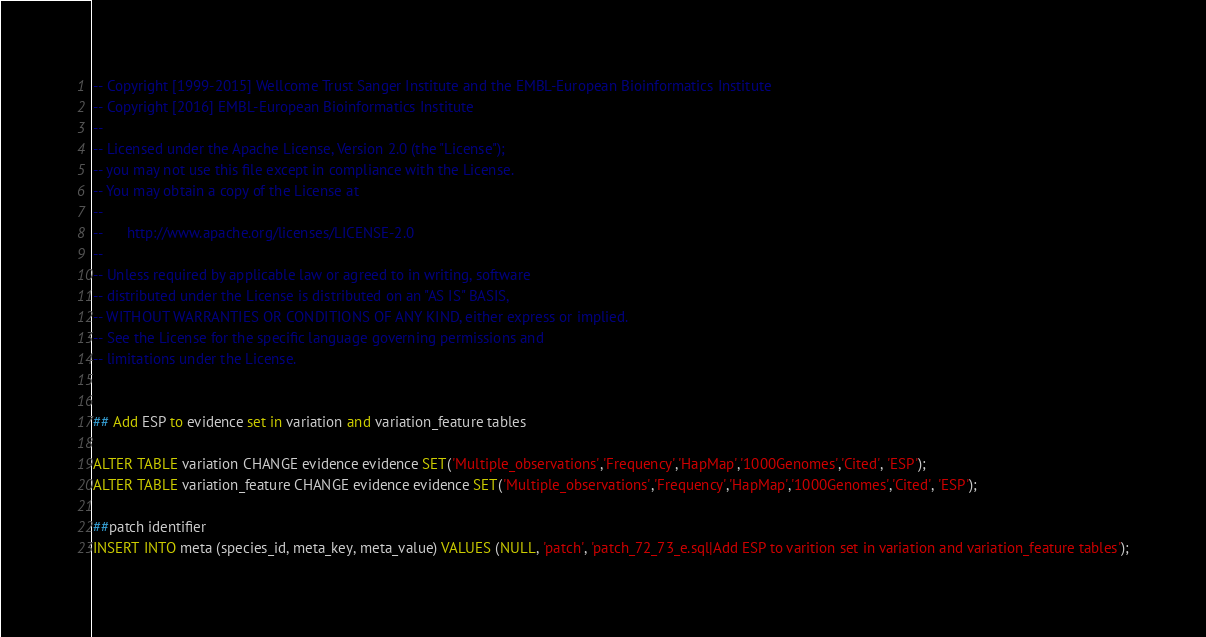<code> <loc_0><loc_0><loc_500><loc_500><_SQL_>-- Copyright [1999-2015] Wellcome Trust Sanger Institute and the EMBL-European Bioinformatics Institute
-- Copyright [2016] EMBL-European Bioinformatics Institute
-- 
-- Licensed under the Apache License, Version 2.0 (the "License");
-- you may not use this file except in compliance with the License.
-- You may obtain a copy of the License at
-- 
--      http://www.apache.org/licenses/LICENSE-2.0
-- 
-- Unless required by applicable law or agreed to in writing, software
-- distributed under the License is distributed on an "AS IS" BASIS,
-- WITHOUT WARRANTIES OR CONDITIONS OF ANY KIND, either express or implied.
-- See the License for the specific language governing permissions and
-- limitations under the License.


## Add ESP to evidence set in variation and variation_feature tables

ALTER TABLE variation CHANGE evidence evidence SET('Multiple_observations','Frequency','HapMap','1000Genomes','Cited', 'ESP');
ALTER TABLE variation_feature CHANGE evidence evidence SET('Multiple_observations','Frequency','HapMap','1000Genomes','Cited', 'ESP');

##patch identifier
INSERT INTO meta (species_id, meta_key, meta_value) VALUES (NULL, 'patch', 'patch_72_73_e.sql|Add ESP to varition set in variation and variation_feature tables');
</code> 